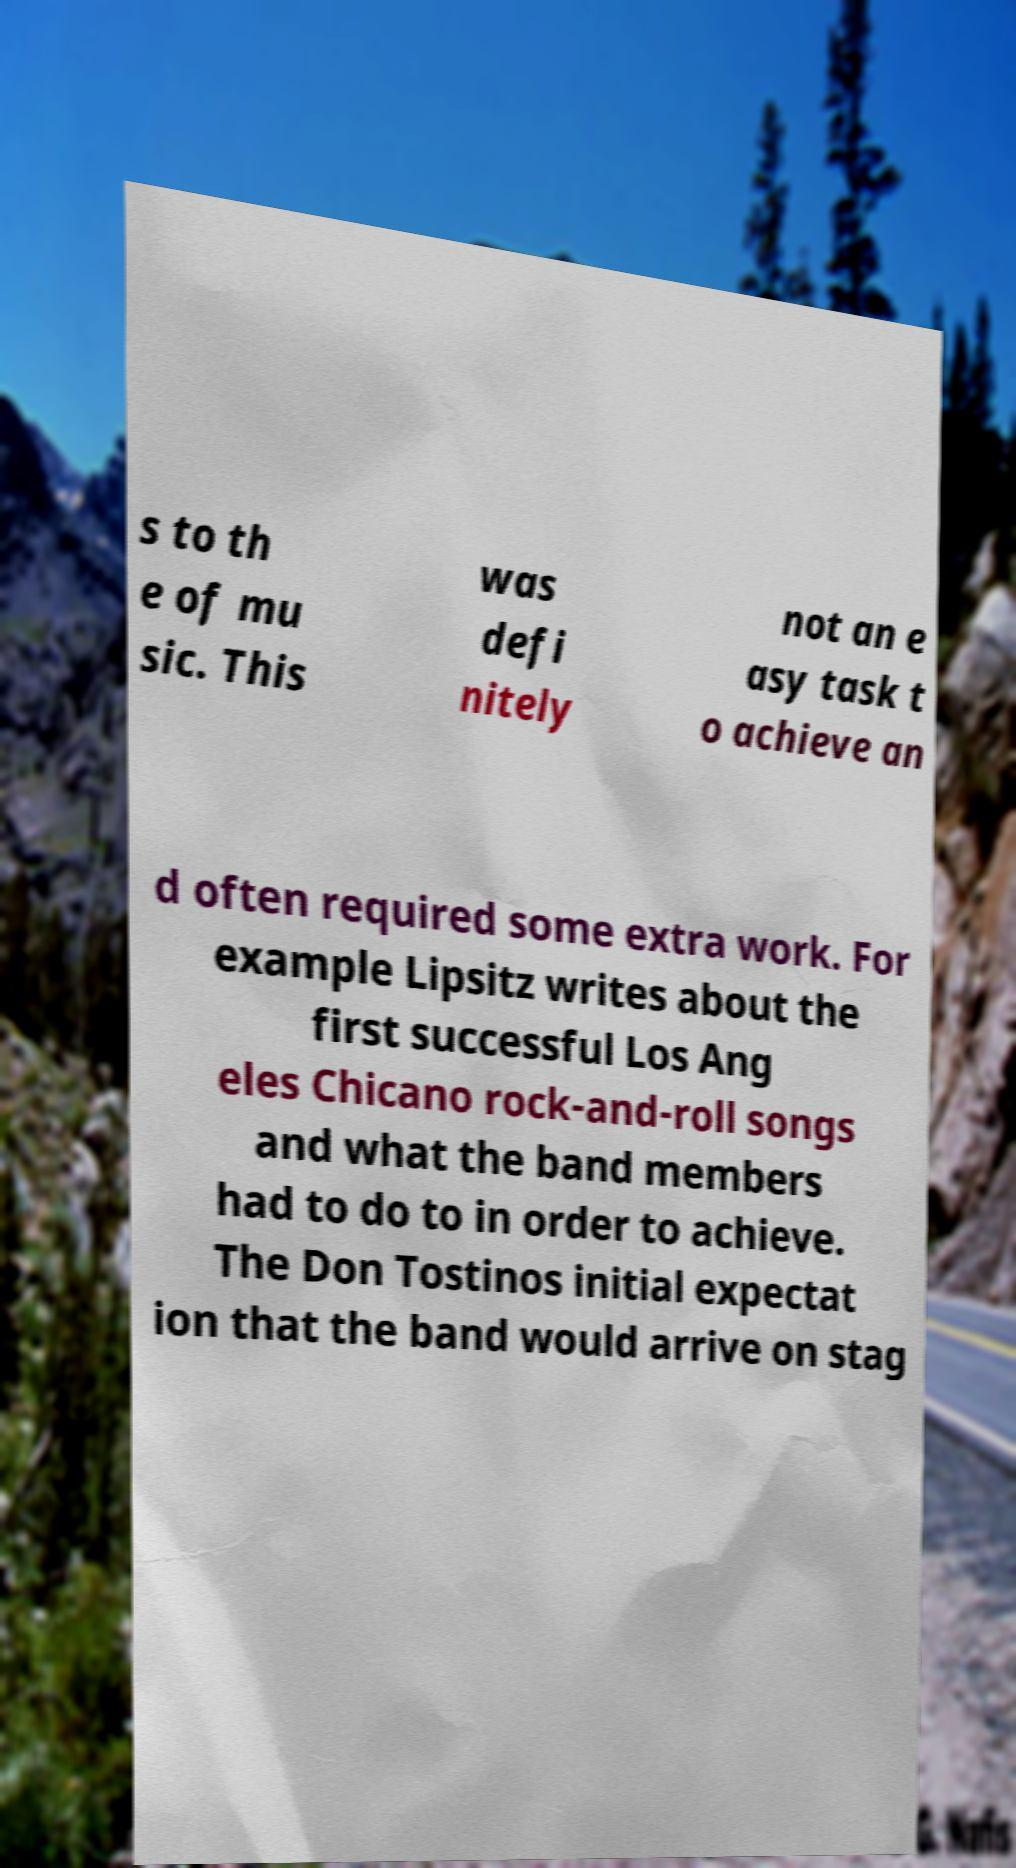There's text embedded in this image that I need extracted. Can you transcribe it verbatim? s to th e of mu sic. This was defi nitely not an e asy task t o achieve an d often required some extra work. For example Lipsitz writes about the first successful Los Ang eles Chicano rock-and-roll songs and what the band members had to do to in order to achieve. The Don Tostinos initial expectat ion that the band would arrive on stag 